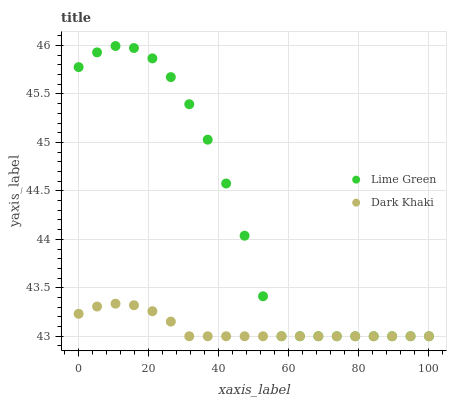Does Dark Khaki have the minimum area under the curve?
Answer yes or no. Yes. Does Lime Green have the maximum area under the curve?
Answer yes or no. Yes. Does Lime Green have the minimum area under the curve?
Answer yes or no. No. Is Dark Khaki the smoothest?
Answer yes or no. Yes. Is Lime Green the roughest?
Answer yes or no. Yes. Is Lime Green the smoothest?
Answer yes or no. No. Does Dark Khaki have the lowest value?
Answer yes or no. Yes. Does Lime Green have the highest value?
Answer yes or no. Yes. Does Dark Khaki intersect Lime Green?
Answer yes or no. Yes. Is Dark Khaki less than Lime Green?
Answer yes or no. No. Is Dark Khaki greater than Lime Green?
Answer yes or no. No. 